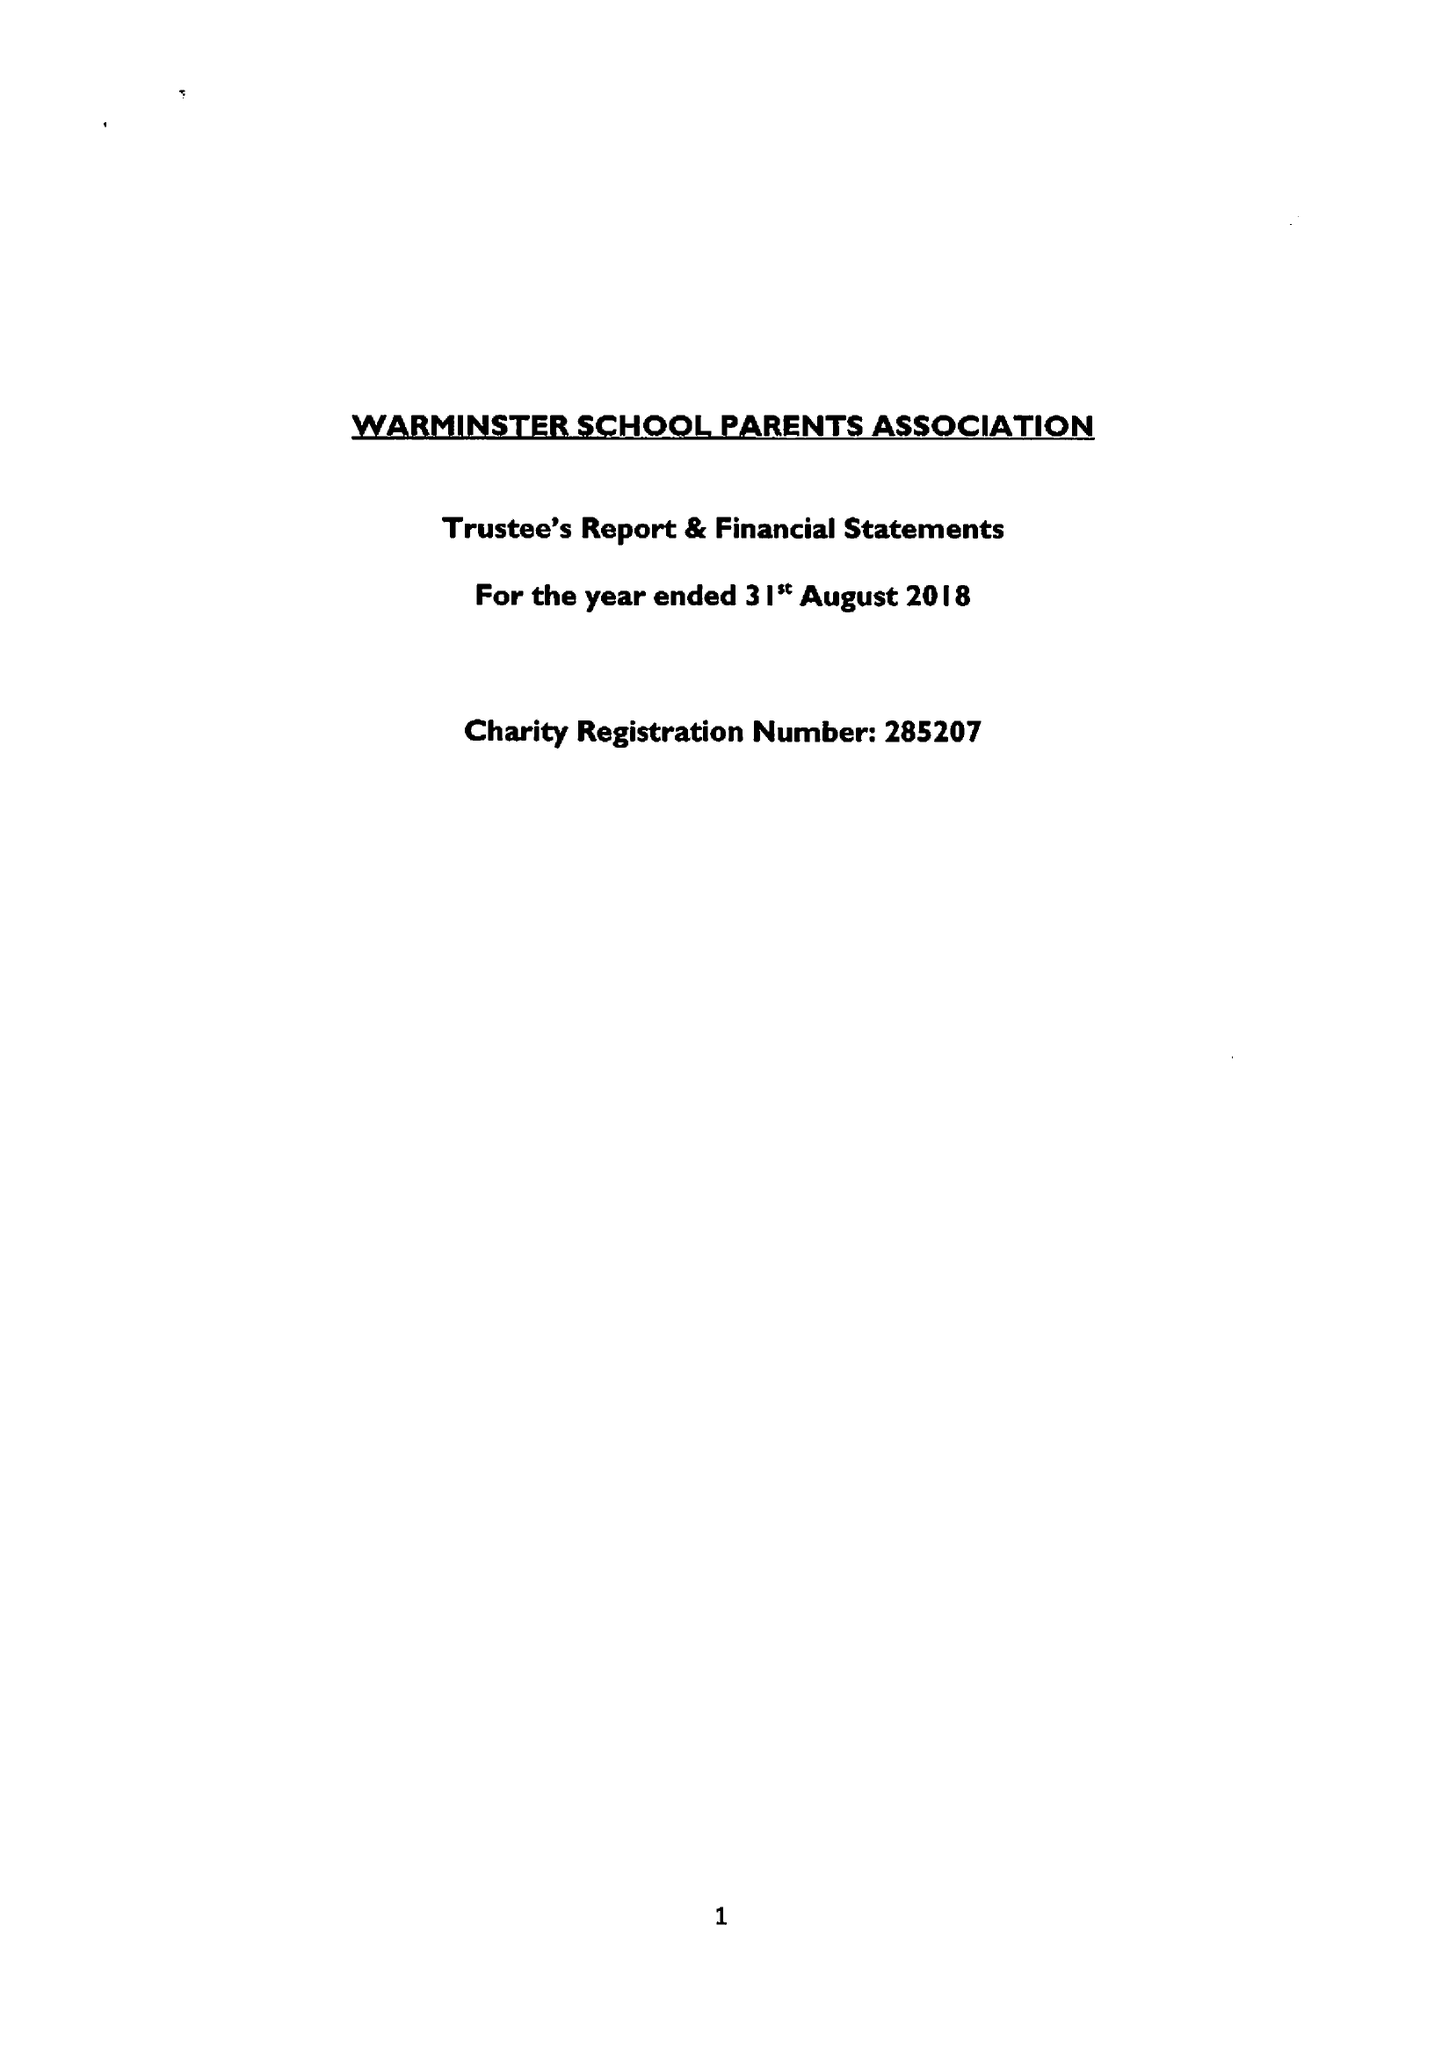What is the value for the spending_annually_in_british_pounds?
Answer the question using a single word or phrase. 48657.00 